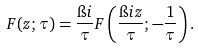<formula> <loc_0><loc_0><loc_500><loc_500>F ( z ; \tau ) = \frac { \i i } { \tau } F \left ( \frac { \i i z } { \tau } ; - \frac { 1 } { \tau } \right ) .</formula> 